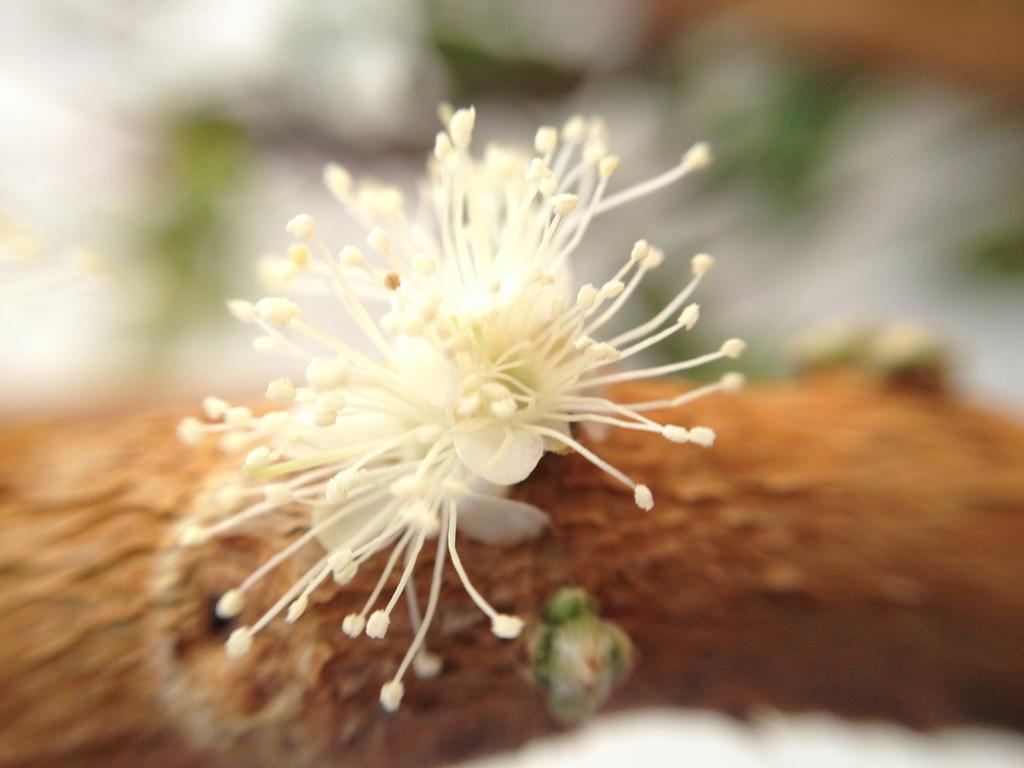What is present in the image? There are flowers in the image. Can you describe the background of the image? The background of the image is blurred. What type of fear is depicted in the image? There is no fear depicted in the image; it features flowers and a blurred background. What type of fork can be seen in the image? There is no fork present in the image. 